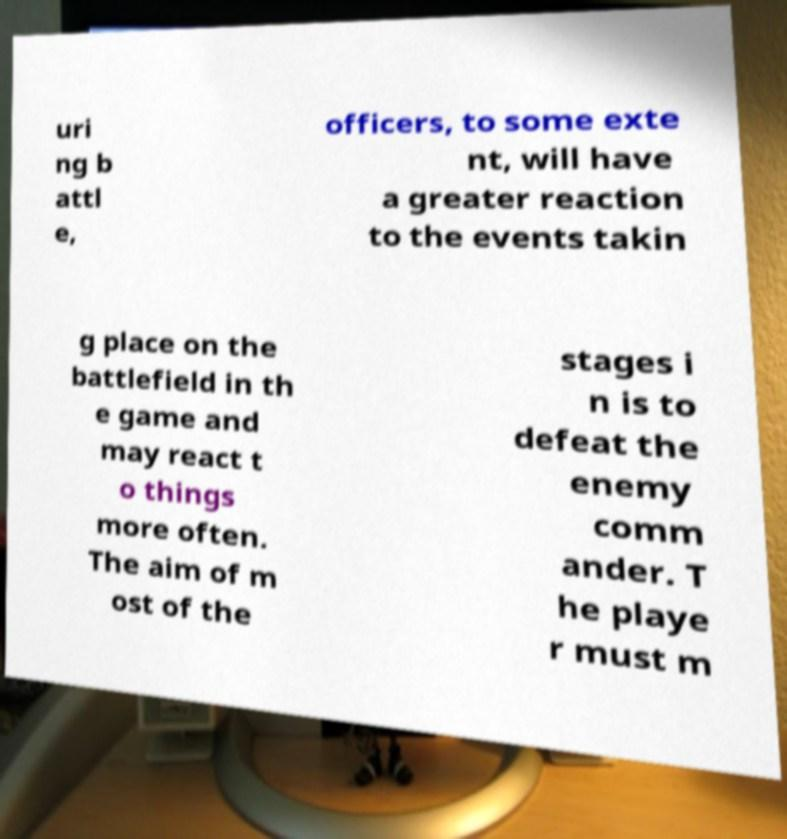Please identify and transcribe the text found in this image. uri ng b attl e, officers, to some exte nt, will have a greater reaction to the events takin g place on the battlefield in th e game and may react t o things more often. The aim of m ost of the stages i n is to defeat the enemy comm ander. T he playe r must m 